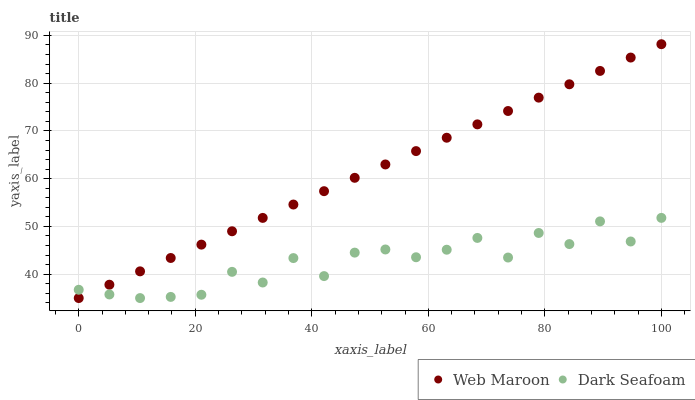Does Dark Seafoam have the minimum area under the curve?
Answer yes or no. Yes. Does Web Maroon have the maximum area under the curve?
Answer yes or no. Yes. Does Web Maroon have the minimum area under the curve?
Answer yes or no. No. Is Web Maroon the smoothest?
Answer yes or no. Yes. Is Dark Seafoam the roughest?
Answer yes or no. Yes. Is Web Maroon the roughest?
Answer yes or no. No. Does Dark Seafoam have the lowest value?
Answer yes or no. Yes. Does Web Maroon have the highest value?
Answer yes or no. Yes. Does Web Maroon intersect Dark Seafoam?
Answer yes or no. Yes. Is Web Maroon less than Dark Seafoam?
Answer yes or no. No. Is Web Maroon greater than Dark Seafoam?
Answer yes or no. No. 